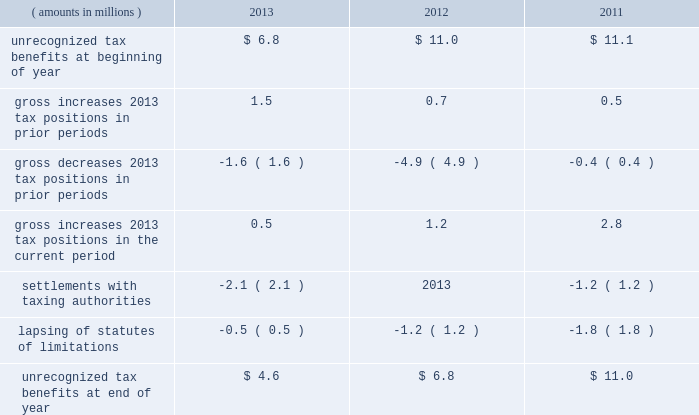A valuation allowance totaling $ 45.4 million , $ 43.9 million and $ 40.4 million as of 2013 , 2012 and 2011 year end , respectively , has been established for deferred income tax assets primarily related to certain subsidiary loss carryforwards that may not be realized .
Realization of the net deferred income tax assets is dependent on generating sufficient taxable income prior to their expiration .
Although realization is not assured , management believes it is more- likely-than-not that the net deferred income tax assets will be realized .
The amount of the net deferred income tax assets considered realizable , however , could change in the near term if estimates of future taxable income during the carryforward period fluctuate .
The following is a reconciliation of the beginning and ending amounts of unrecognized tax benefits for 2013 , 2012 and ( amounts in millions ) 2013 2012 2011 .
Of the $ 4.6 million , $ 6.8 million and $ 11.0 million of unrecognized tax benefits as of 2013 , 2012 and 2011 year end , respectively , approximately $ 4.6 million , $ 4.1 million and $ 9.1 million , respectively , would impact the effective income tax rate if recognized .
Interest and penalties related to unrecognized tax benefits are recorded in income tax expense .
During 2013 and 2012 , the company reversed a net $ 0.6 million and $ 0.5 million , respectively , of interest and penalties to income associated with unrecognized tax benefits .
As of 2013 , 2012 and 2011 year end , the company has provided for $ 0.9 million , $ 1.6 million and $ 1.6 million , respectively , of accrued interest and penalties related to unrecognized tax benefits .
The unrecognized tax benefits and related accrued interest and penalties are included in 201cother long-term liabilities 201d on the accompanying consolidated balance sheets .
Snap-on and its subsidiaries file income tax returns in the united states and in various state , local and foreign jurisdictions .
It is reasonably possible that certain unrecognized tax benefits may either be settled with taxing authorities or the statutes of limitations for such items may lapse within the next 12 months , causing snap-on 2019s gross unrecognized tax benefits to decrease by a range of zero to $ 1.1 million .
Over the next 12 months , snap-on anticipates taking certain tax positions on various tax returns for which the related tax benefit does not meet the recognition threshold .
Accordingly , snap-on 2019s gross unrecognized tax benefits may increase by a range of zero to $ 0.8 million over the next 12 months for uncertain tax positions expected to be taken in future tax filings .
With few exceptions , snap-on is no longer subject to u.s .
Federal and state/local income tax examinations by tax authorities for years prior to 2008 , and snap-on is no longer subject to non-u.s .
Income tax examinations by tax authorities for years prior to 2006 .
The undistributed earnings of all non-u.s .
Subsidiaries totaled $ 556.0 million , $ 492.2 million and $ 416.4 million as of 2013 , 2012 and 2011 year end , respectively .
Snap-on has not provided any deferred taxes on these undistributed earnings as it considers the undistributed earnings to be permanently invested .
Determination of the amount of unrecognized deferred income tax liability related to these earnings is not practicable .
2013 annual report 83 .
From 2011 to 2013 what was the average gross increases 2013 tax positions in prior periods? 
Computations: ((0.7 / (1.5 + 0.5)) / 3)
Answer: 0.11667. 